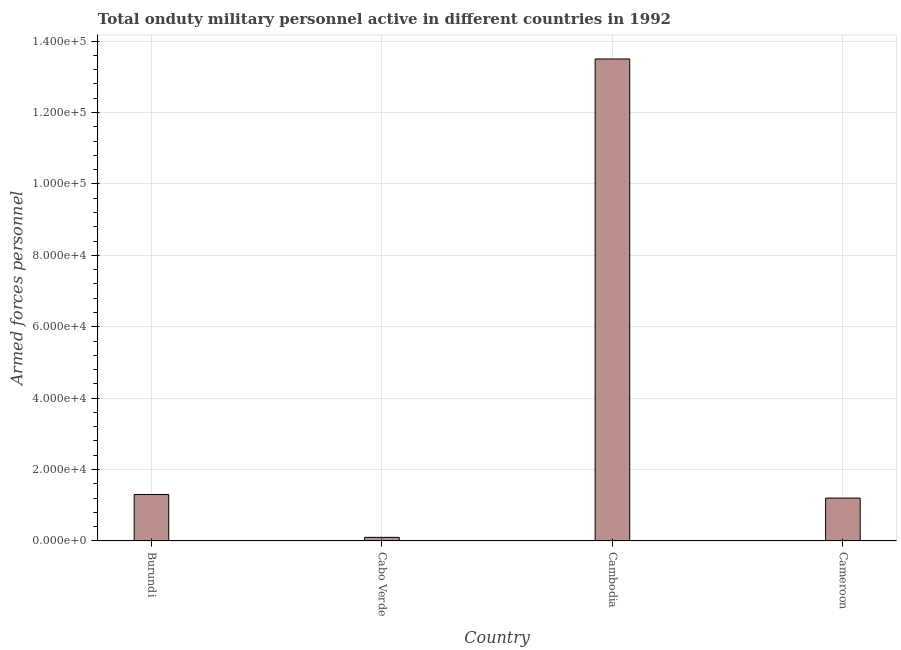Does the graph contain any zero values?
Give a very brief answer. No. Does the graph contain grids?
Provide a succinct answer. Yes. What is the title of the graph?
Ensure brevity in your answer.  Total onduty military personnel active in different countries in 1992. What is the label or title of the X-axis?
Provide a succinct answer. Country. What is the label or title of the Y-axis?
Offer a very short reply. Armed forces personnel. What is the number of armed forces personnel in Cambodia?
Provide a succinct answer. 1.35e+05. Across all countries, what is the maximum number of armed forces personnel?
Offer a terse response. 1.35e+05. In which country was the number of armed forces personnel maximum?
Provide a succinct answer. Cambodia. In which country was the number of armed forces personnel minimum?
Keep it short and to the point. Cabo Verde. What is the sum of the number of armed forces personnel?
Offer a terse response. 1.61e+05. What is the difference between the number of armed forces personnel in Burundi and Cambodia?
Your answer should be compact. -1.22e+05. What is the average number of armed forces personnel per country?
Offer a terse response. 4.02e+04. What is the median number of armed forces personnel?
Keep it short and to the point. 1.25e+04. What is the ratio of the number of armed forces personnel in Cabo Verde to that in Cambodia?
Your answer should be very brief. 0.01. Is the difference between the number of armed forces personnel in Cabo Verde and Cameroon greater than the difference between any two countries?
Your answer should be compact. No. What is the difference between the highest and the second highest number of armed forces personnel?
Your answer should be very brief. 1.22e+05. What is the difference between the highest and the lowest number of armed forces personnel?
Your response must be concise. 1.34e+05. In how many countries, is the number of armed forces personnel greater than the average number of armed forces personnel taken over all countries?
Make the answer very short. 1. How many bars are there?
Your answer should be compact. 4. How many countries are there in the graph?
Your response must be concise. 4. What is the Armed forces personnel of Burundi?
Your response must be concise. 1.30e+04. What is the Armed forces personnel of Cambodia?
Provide a succinct answer. 1.35e+05. What is the Armed forces personnel in Cameroon?
Provide a short and direct response. 1.20e+04. What is the difference between the Armed forces personnel in Burundi and Cabo Verde?
Give a very brief answer. 1.20e+04. What is the difference between the Armed forces personnel in Burundi and Cambodia?
Offer a terse response. -1.22e+05. What is the difference between the Armed forces personnel in Burundi and Cameroon?
Your answer should be compact. 1000. What is the difference between the Armed forces personnel in Cabo Verde and Cambodia?
Make the answer very short. -1.34e+05. What is the difference between the Armed forces personnel in Cabo Verde and Cameroon?
Give a very brief answer. -1.10e+04. What is the difference between the Armed forces personnel in Cambodia and Cameroon?
Keep it short and to the point. 1.23e+05. What is the ratio of the Armed forces personnel in Burundi to that in Cambodia?
Offer a terse response. 0.1. What is the ratio of the Armed forces personnel in Burundi to that in Cameroon?
Keep it short and to the point. 1.08. What is the ratio of the Armed forces personnel in Cabo Verde to that in Cambodia?
Give a very brief answer. 0.01. What is the ratio of the Armed forces personnel in Cabo Verde to that in Cameroon?
Give a very brief answer. 0.08. What is the ratio of the Armed forces personnel in Cambodia to that in Cameroon?
Offer a very short reply. 11.25. 